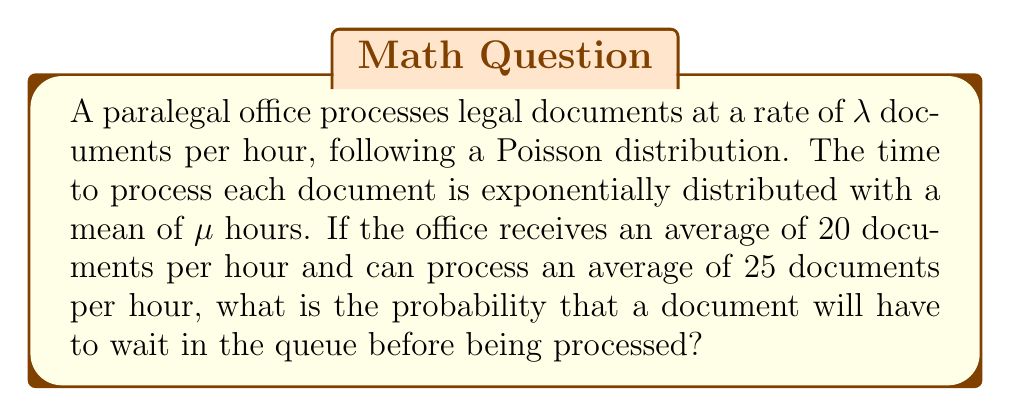Can you solve this math problem? To solve this problem, we'll use the M/M/1 queuing model, which is appropriate for this scenario. Let's follow these steps:

1. Identify the parameters:
   $\lambda = 20$ documents/hour (arrival rate)
   $\mu = 25$ documents/hour (service rate)

2. Calculate the utilization factor $\rho$:
   $$\rho = \frac{\lambda}{\mu} = \frac{20}{25} = 0.8$$

3. In an M/M/1 queue, the probability that an arriving customer (document) has to wait is equal to the utilization factor $\rho$.

4. Therefore, the probability that a document will have to wait in the queue is 0.8 or 80%.

This result indicates that the paralegal office is quite busy, with a high probability of documents waiting to be processed. As a legal journalist, this information could be used to report on the efficiency and workload of paralegal offices, highlighting the importance of their work and potentially advocating for increased resources or improved processes.
Answer: 0.8 